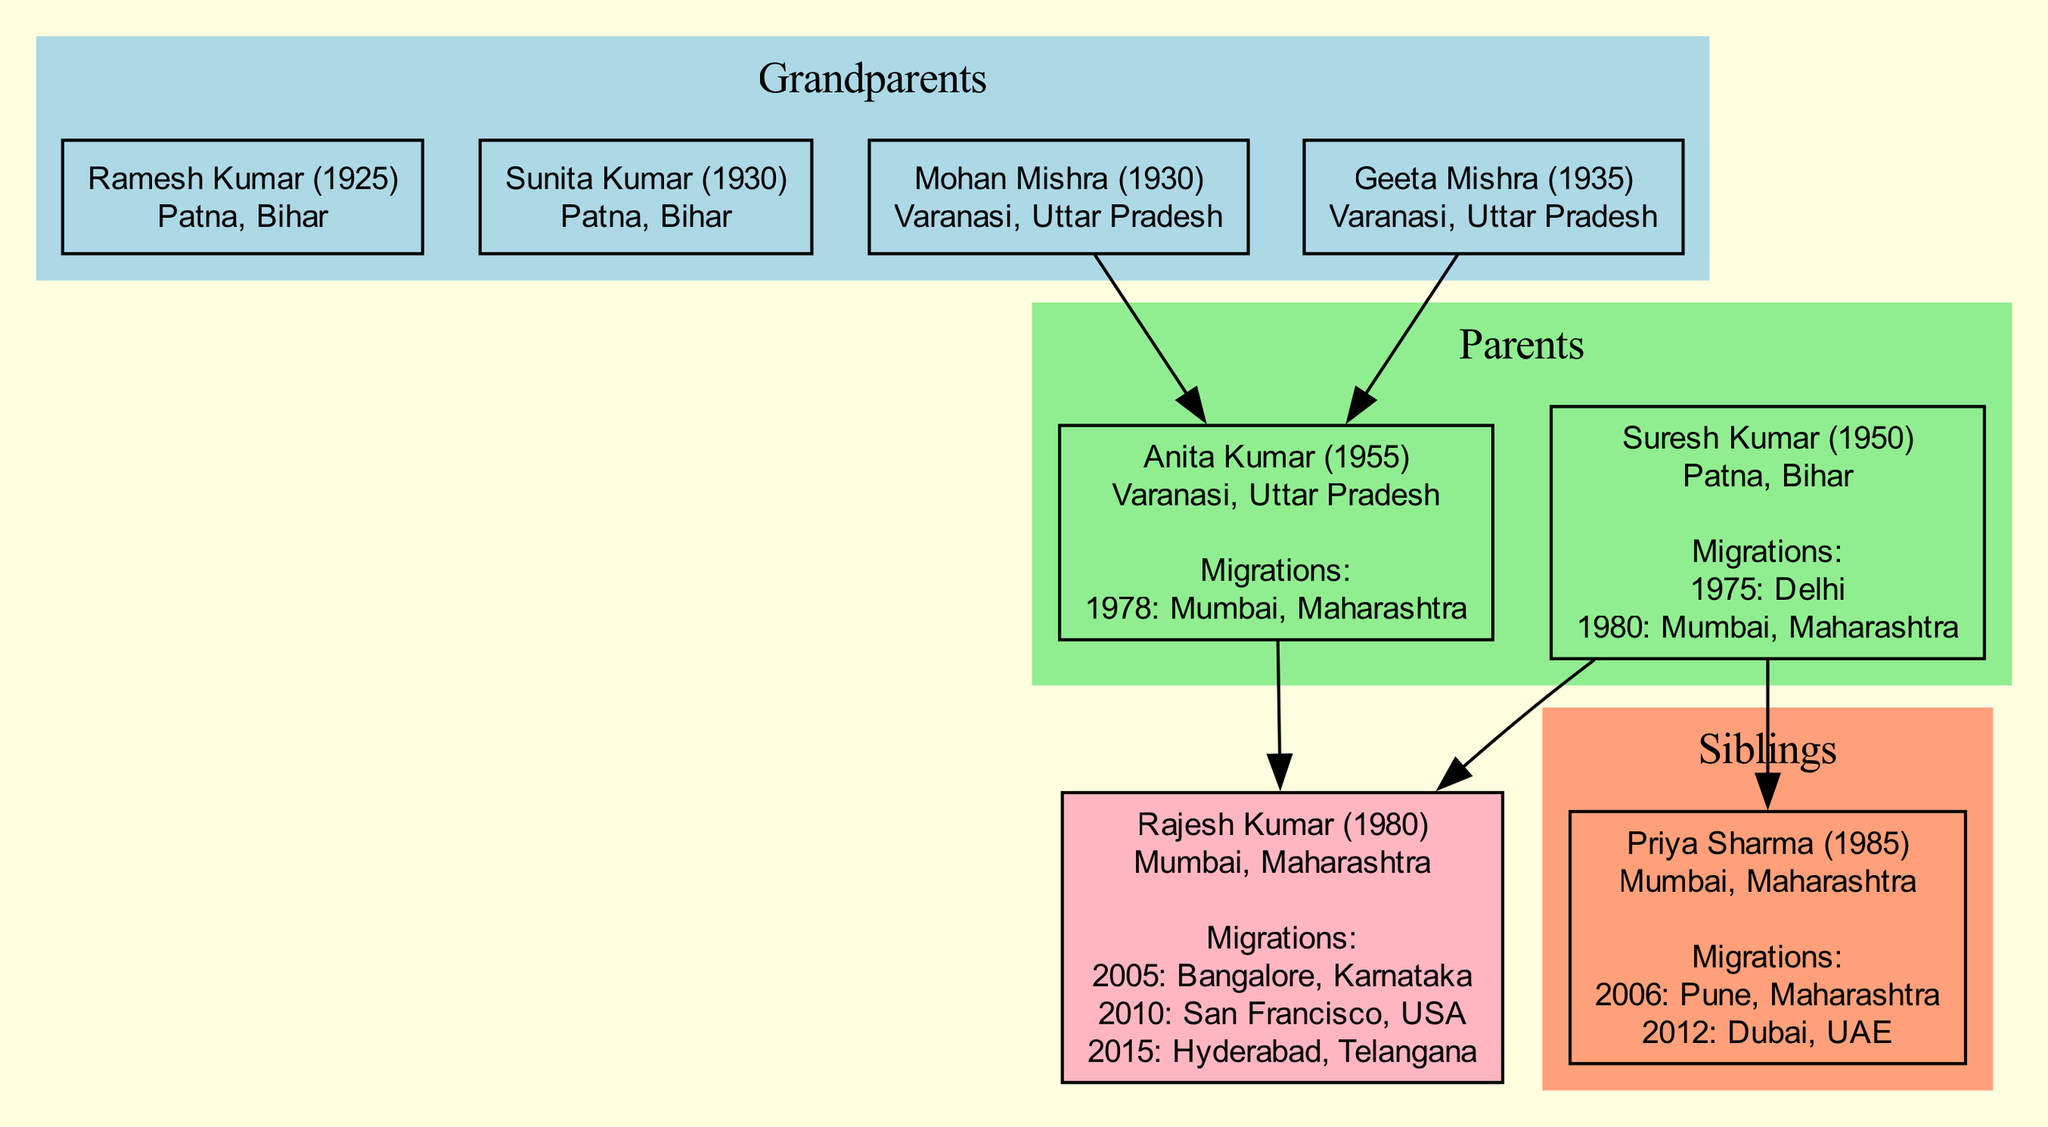What is Rajesh Kumar's birth year? By examining the diagram, Rajesh Kumar's birth year is presented directly in the label associated with his node. It states "Rajesh Kumar (1980)", indicating that he was born in the year 1980.
Answer: 1980 Where was Anita Kumar born? The diagram displays the birthplaces of individuals. In Anita Kumar's label, it shows "Varanasi, Uttar Pradesh", confirming her birthplace.
Answer: Varanasi, Uttar Pradesh What was the reason for Priya Sharma's first migration? Looking at Priya Sharma's migration history in the diagram, her first migration entry states "2006, Pune, Maharashtra, Higher Education". Therefore, the reason for her first migration is specified as higher education.
Answer: Higher Education How many migrations did Rajesh Kumar undertake? The migration history for Rajesh Kumar lists three entries: 2005 to Bangalore, 2010 to San Francisco, and 2015 to Hyderabad. Counting these entries gives us the total migrations undertaken, which is three.
Answer: 3 Which parent migrated for higher education? Upon reviewing the migration histories, Suresh Kumar's first migration in 1975 is documented as being for "Higher Education". Thus, he is the parent who migrated for this reason.
Answer: Suresh Kumar Who is the maternal grandmother of Rajesh Kumar? The diagram provides the names and relationships of Rajesh Kumar's grandparents. It states that "Geeta Mishra" is positioned as his maternal grandmother, identifying her role in the family tree.
Answer: Geeta Mishra What year did Suresh Kumar move to Mumbai? In analyzing Suresh Kumar's migration history in the diagram, the entry states he moved to Mumbai in 1980 for a job transfer. This indicates the year of that specific migration.
Answer: 1980 In which country did Priya Sharma migrate last? The diagram reflects that Priya Sharma's last migration occurred in 2012, with the destination being "Dubai, UAE". This indicates her most recent move took her to a different country.
Answer: UAE 